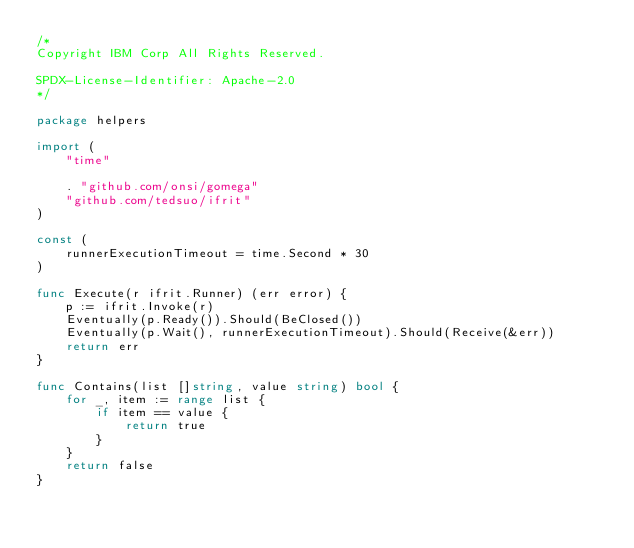Convert code to text. <code><loc_0><loc_0><loc_500><loc_500><_Go_>/*
Copyright IBM Corp All Rights Reserved.

SPDX-License-Identifier: Apache-2.0
*/

package helpers

import (
	"time"

	. "github.com/onsi/gomega"
	"github.com/tedsuo/ifrit"
)

const (
	runnerExecutionTimeout = time.Second * 30
)

func Execute(r ifrit.Runner) (err error) {
	p := ifrit.Invoke(r)
	Eventually(p.Ready()).Should(BeClosed())
	Eventually(p.Wait(), runnerExecutionTimeout).Should(Receive(&err))
	return err
}

func Contains(list []string, value string) bool {
	for _, item := range list {
		if item == value {
			return true
		}
	}
	return false
}
</code> 